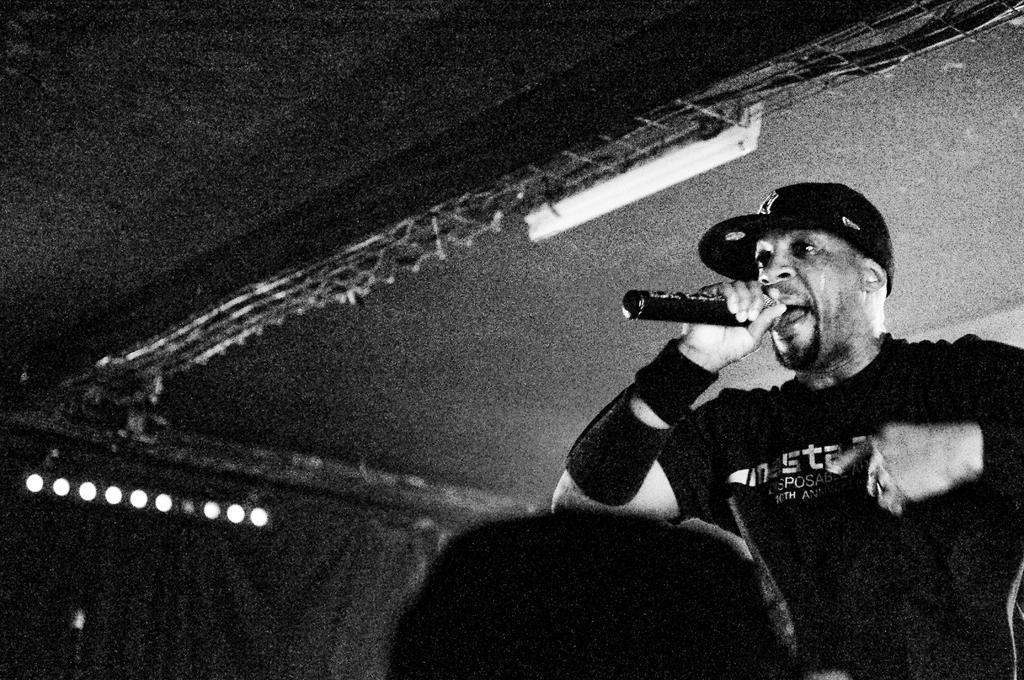Please provide a concise description of this image. In this picture we can see a man is singing with the help of microphone, in the background we can see metal rod and some lights. 